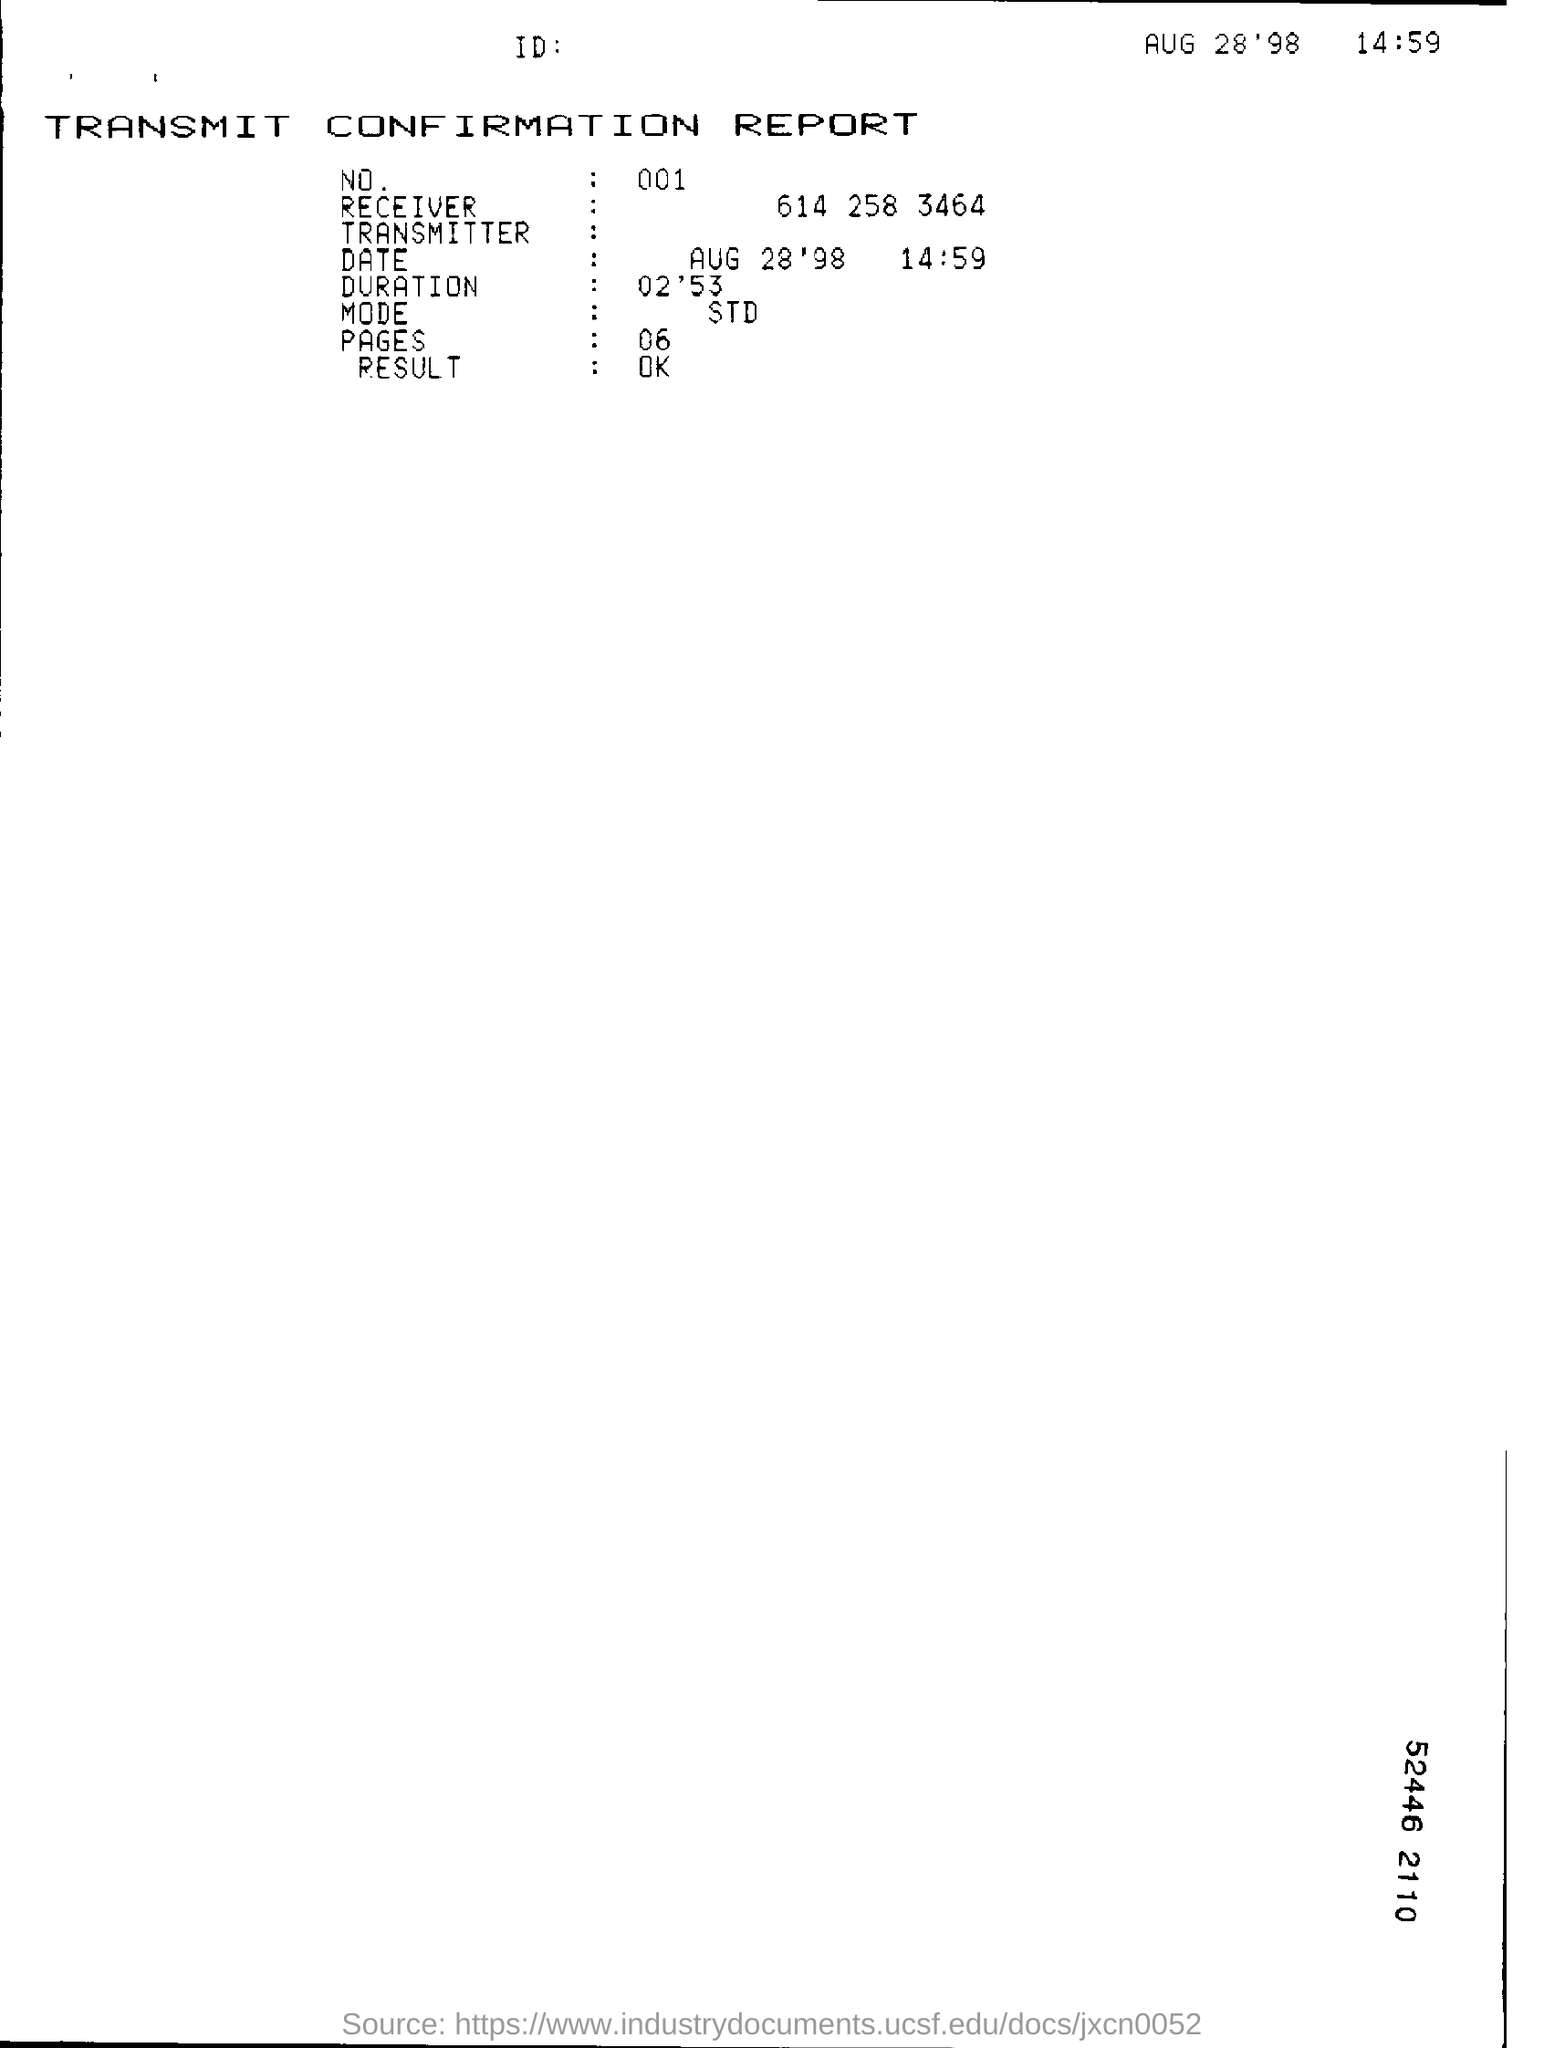What is the name of the document ?
Provide a succinct answer. TRANSMIT CONFIRMATION REPORT. What is the date mention in this document?
Your answer should be very brief. Aug 28'98. What is no mention in this document?
Give a very brief answer. 001. What is the duration time mention in this document ?
Ensure brevity in your answer.  02'53. What  is the mode  mention in this document?
Make the answer very short. STD. How many pages are there?
Provide a succinct answer. 06. What is the result mention in this document ?
Your answer should be very brief. Ok. 